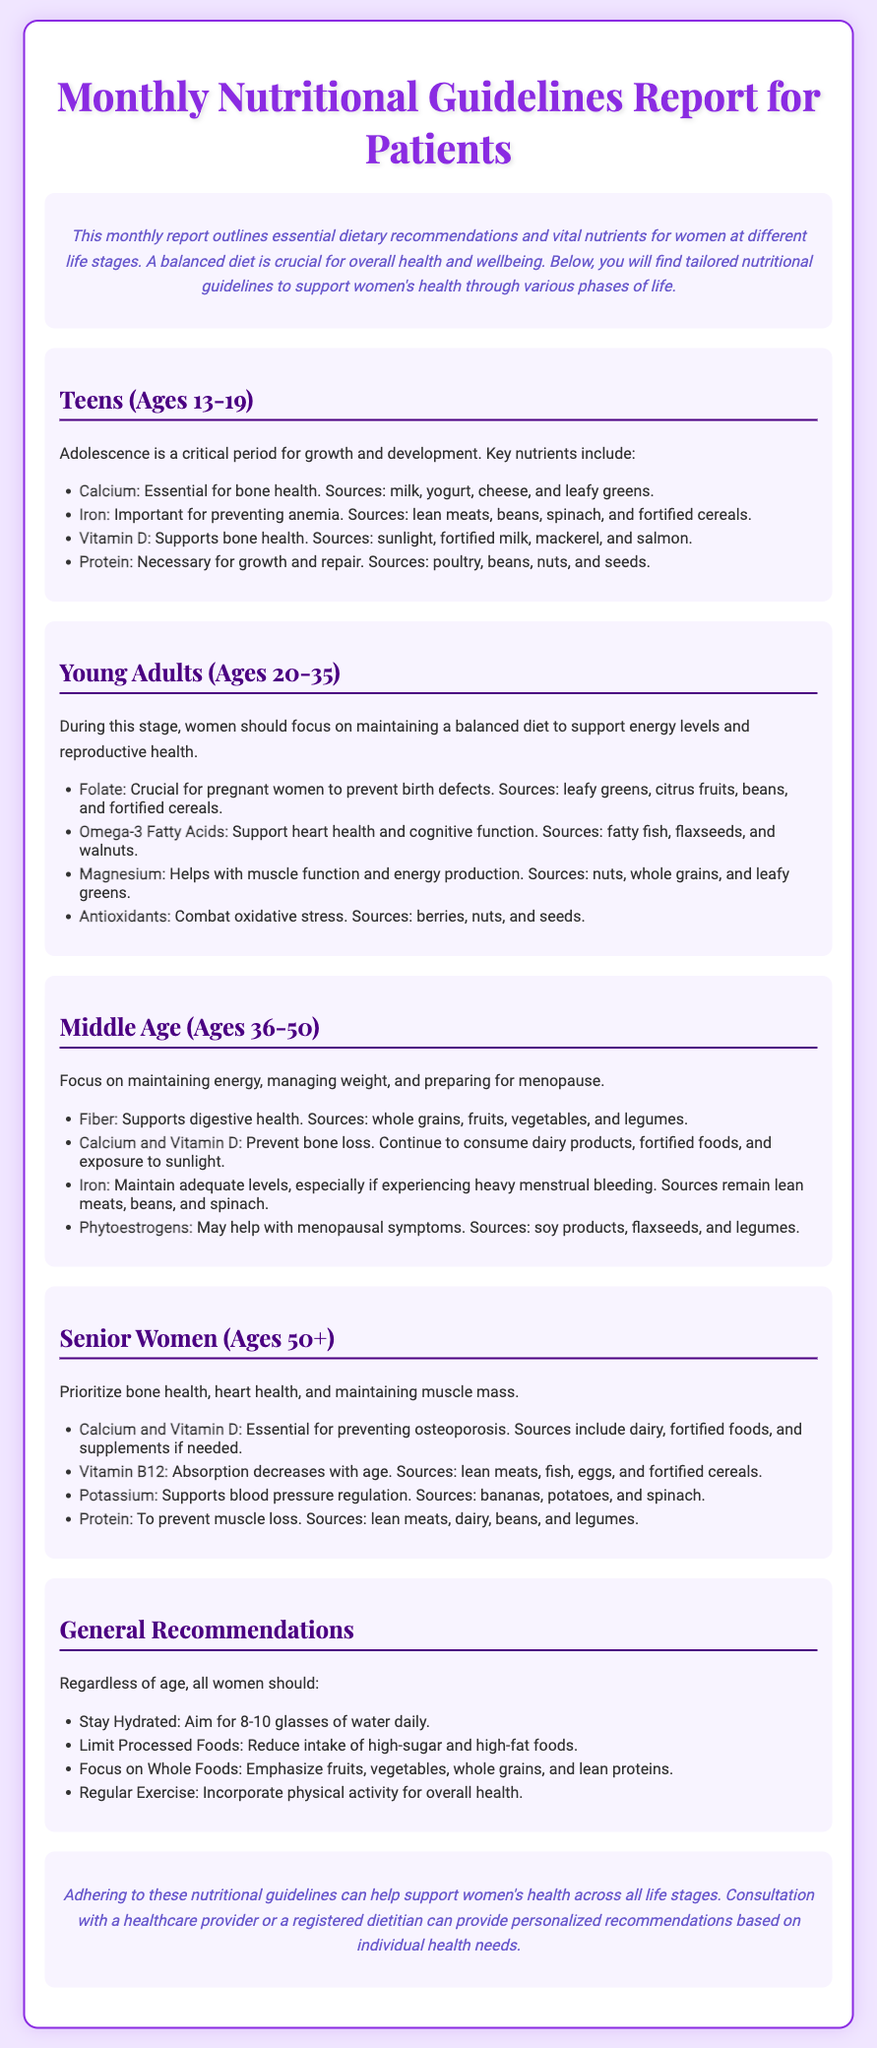What are the key nutrients for teens? The document lists Calcium, Iron, Vitamin D, and Protein as key nutrients for teens.
Answer: Calcium, Iron, Vitamin D, Protein What should young adults focus on for nutrition? The document mentions maintaining a balanced diet to support energy levels and reproductive health during young adulthood.
Answer: Balanced diet Which nutrient is crucial for preventing birth defects? The document states that Folate is crucial for preventing birth defects in pregnant women.
Answer: Folate What are good sources of Iron for middle-aged women? Lean meats, beans, and spinach are listed as good sources of Iron for middle-aged women.
Answer: Lean meats, beans, spinach What essential vitamins are highlighted for senior women? The document emphasizes Calcium, Vitamin D, Vitamin B12, and Protein for senior women.
Answer: Calcium, Vitamin D, Vitamin B12, Protein What is a general recommendation for hydration? The document recommends aiming for 8-10 glasses of water daily as part of general recommendations.
Answer: 8-10 glasses What dietary aspect should be limited for women of all ages? The document suggests limiting processed foods, specifically high-sugar and high-fat foods.
Answer: Processed foods What is the purpose of the Monthly Nutritional Guidelines Report? It outlines essential dietary recommendations and vital nutrients for women at different life stages.
Answer: Dietary recommendations What is included in the introduction section of the playbill? It includes an overview of the importance of a balanced diet for overall health and wellbeing for women.
Answer: Overview of dietary importance 